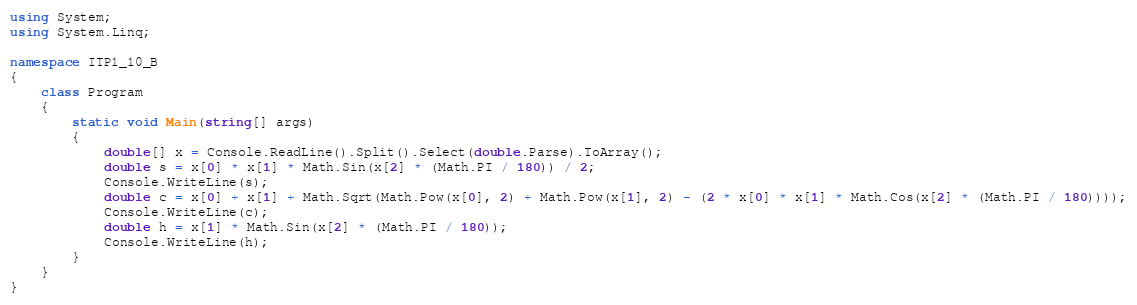Convert code to text. <code><loc_0><loc_0><loc_500><loc_500><_C#_>using System;
using System.Linq;

namespace ITP1_10_B
{
    class Program
    {
        static void Main(string[] args)
        {
            double[] x = Console.ReadLine().Split().Select(double.Parse).ToArray();
            double s = x[0] * x[1] * Math.Sin(x[2] * (Math.PI / 180)) / 2;
            Console.WriteLine(s);
            double c = x[0] + x[1] + Math.Sqrt(Math.Pow(x[0], 2) + Math.Pow(x[1], 2) - (2 * x[0] * x[1] * Math.Cos(x[2] * (Math.PI / 180))));
            Console.WriteLine(c);
            double h = x[1] * Math.Sin(x[2] * (Math.PI / 180));
            Console.WriteLine(h);
        }
    }
}
</code> 